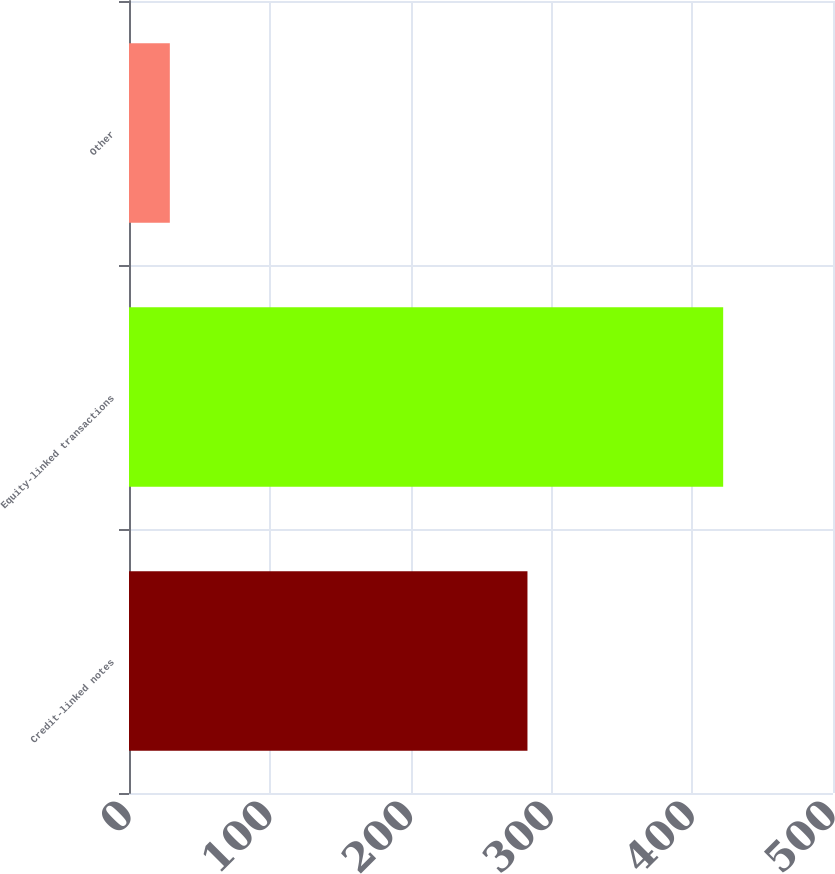<chart> <loc_0><loc_0><loc_500><loc_500><bar_chart><fcel>Credit-linked notes<fcel>Equity-linked transactions<fcel>Other<nl><fcel>283<fcel>422<fcel>29<nl></chart> 